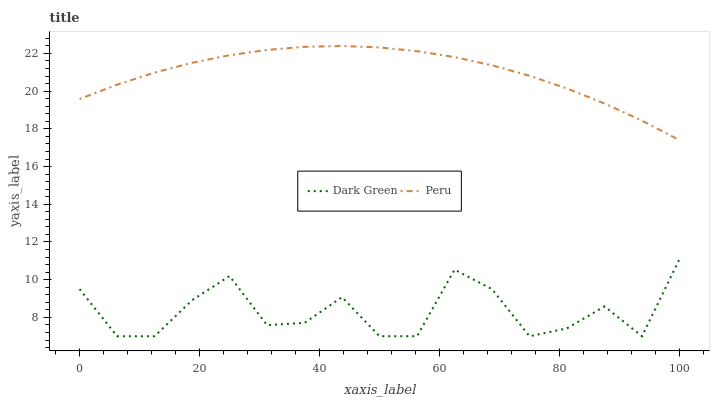Does Dark Green have the minimum area under the curve?
Answer yes or no. Yes. Does Peru have the maximum area under the curve?
Answer yes or no. Yes. Does Dark Green have the maximum area under the curve?
Answer yes or no. No. Is Peru the smoothest?
Answer yes or no. Yes. Is Dark Green the roughest?
Answer yes or no. Yes. Is Dark Green the smoothest?
Answer yes or no. No. Does Dark Green have the lowest value?
Answer yes or no. Yes. Does Peru have the highest value?
Answer yes or no. Yes. Does Dark Green have the highest value?
Answer yes or no. No. Is Dark Green less than Peru?
Answer yes or no. Yes. Is Peru greater than Dark Green?
Answer yes or no. Yes. Does Dark Green intersect Peru?
Answer yes or no. No. 